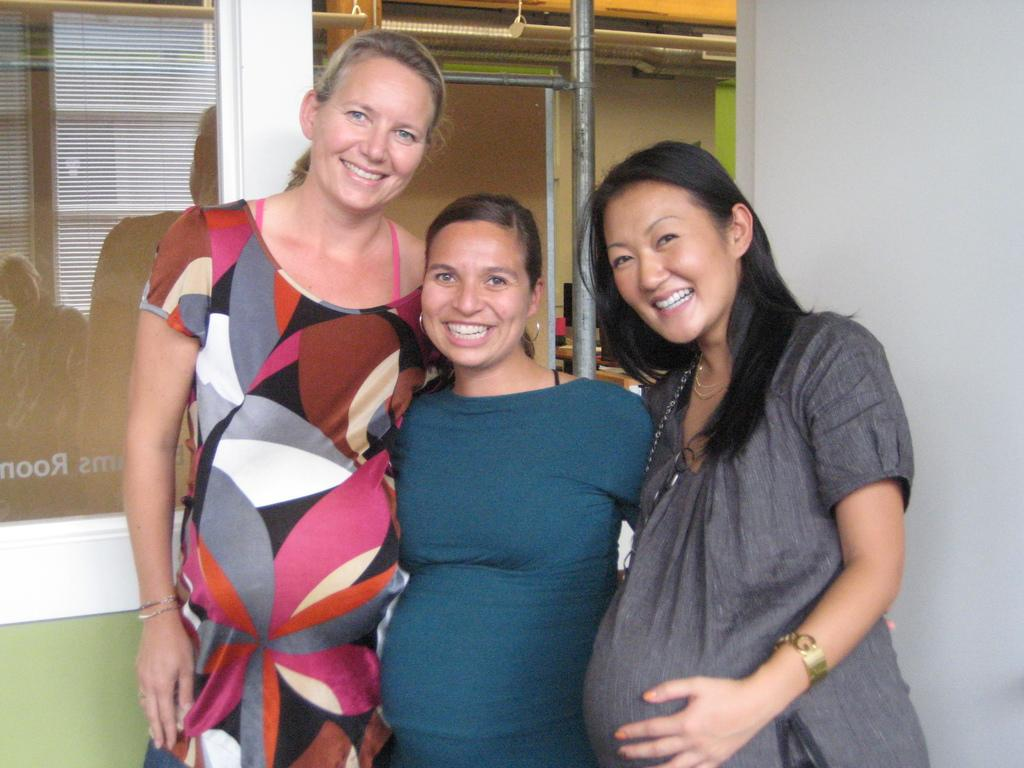How many pregnant women are in the image? There are 3 pregnant women in the image. What are the pregnant women doing in the image? The pregnant women are standing. What can be seen behind the pregnant women? There is a pole behind the pregnant women. What type of building can be seen in the image? There is no building present in the image. 